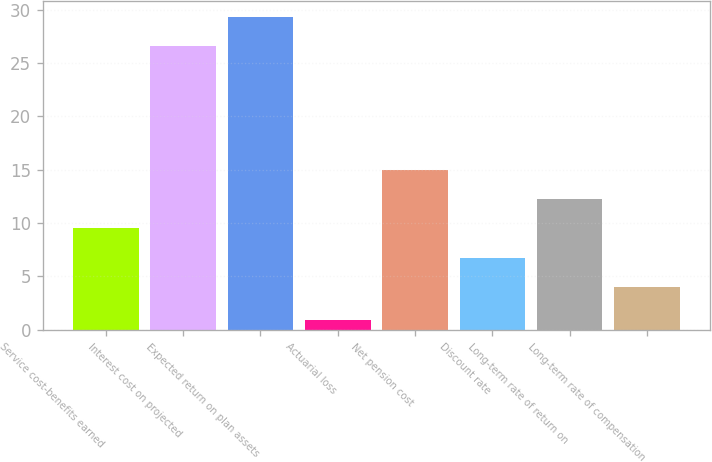Convert chart. <chart><loc_0><loc_0><loc_500><loc_500><bar_chart><fcel>Service cost-benefits earned<fcel>Interest cost on projected<fcel>Expected return on plan assets<fcel>Actuarial loss<fcel>Net pension cost<fcel>Discount rate<fcel>Long-term rate of return on<fcel>Long-term rate of compensation<nl><fcel>9.5<fcel>26.6<fcel>29.34<fcel>0.9<fcel>14.98<fcel>6.76<fcel>12.24<fcel>4.02<nl></chart> 